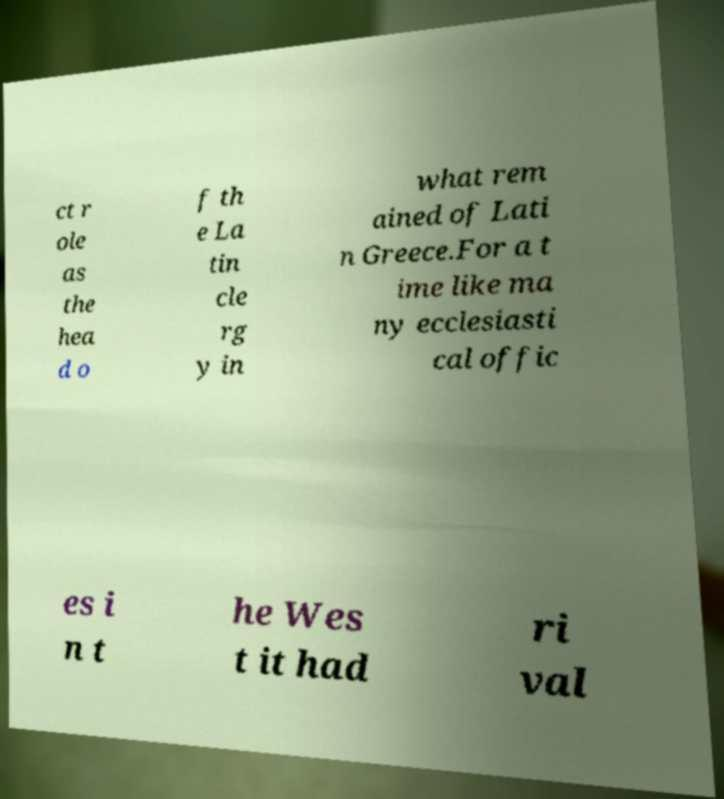I need the written content from this picture converted into text. Can you do that? ct r ole as the hea d o f th e La tin cle rg y in what rem ained of Lati n Greece.For a t ime like ma ny ecclesiasti cal offic es i n t he Wes t it had ri val 